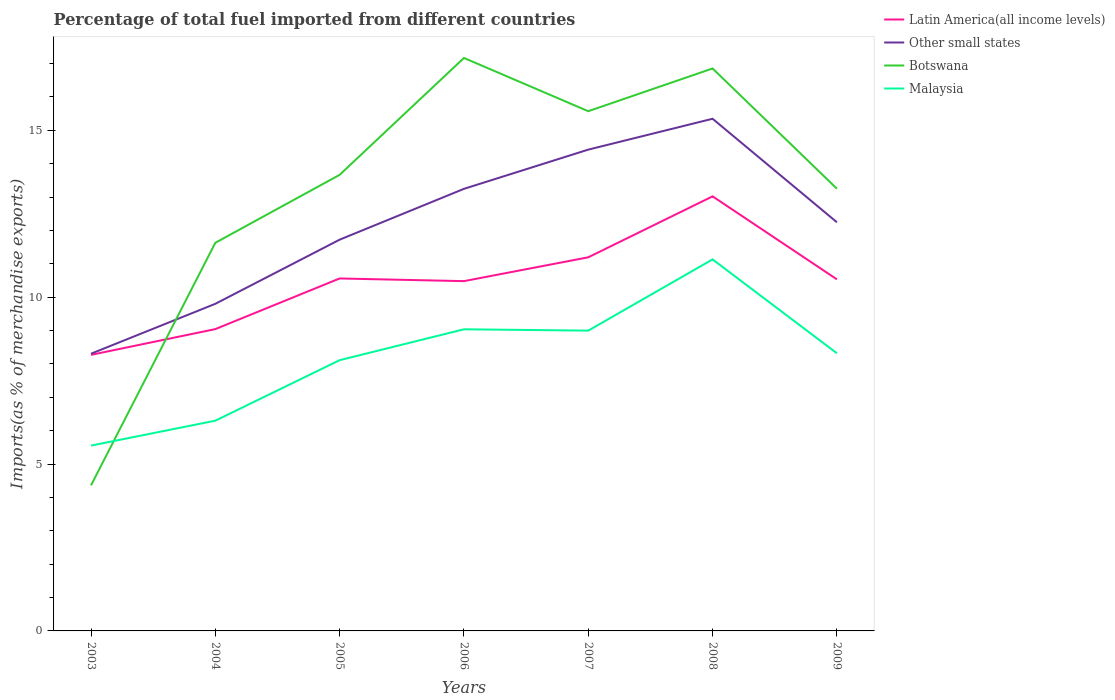Across all years, what is the maximum percentage of imports to different countries in Botswana?
Provide a short and direct response. 4.36. What is the total percentage of imports to different countries in Malaysia in the graph?
Your answer should be compact. -0.93. What is the difference between the highest and the second highest percentage of imports to different countries in Botswana?
Your response must be concise. 12.81. How many years are there in the graph?
Offer a very short reply. 7. Does the graph contain grids?
Provide a short and direct response. No. How many legend labels are there?
Your answer should be compact. 4. How are the legend labels stacked?
Your response must be concise. Vertical. What is the title of the graph?
Your response must be concise. Percentage of total fuel imported from different countries. Does "Switzerland" appear as one of the legend labels in the graph?
Your response must be concise. No. What is the label or title of the Y-axis?
Keep it short and to the point. Imports(as % of merchandise exports). What is the Imports(as % of merchandise exports) of Latin America(all income levels) in 2003?
Provide a succinct answer. 8.27. What is the Imports(as % of merchandise exports) in Other small states in 2003?
Offer a very short reply. 8.31. What is the Imports(as % of merchandise exports) of Botswana in 2003?
Make the answer very short. 4.36. What is the Imports(as % of merchandise exports) of Malaysia in 2003?
Provide a short and direct response. 5.55. What is the Imports(as % of merchandise exports) of Latin America(all income levels) in 2004?
Ensure brevity in your answer.  9.04. What is the Imports(as % of merchandise exports) of Other small states in 2004?
Your answer should be compact. 9.8. What is the Imports(as % of merchandise exports) of Botswana in 2004?
Ensure brevity in your answer.  11.63. What is the Imports(as % of merchandise exports) in Malaysia in 2004?
Offer a terse response. 6.3. What is the Imports(as % of merchandise exports) in Latin America(all income levels) in 2005?
Ensure brevity in your answer.  10.56. What is the Imports(as % of merchandise exports) of Other small states in 2005?
Keep it short and to the point. 11.72. What is the Imports(as % of merchandise exports) of Botswana in 2005?
Provide a short and direct response. 13.66. What is the Imports(as % of merchandise exports) in Malaysia in 2005?
Ensure brevity in your answer.  8.11. What is the Imports(as % of merchandise exports) of Latin America(all income levels) in 2006?
Your answer should be very brief. 10.48. What is the Imports(as % of merchandise exports) of Other small states in 2006?
Make the answer very short. 13.25. What is the Imports(as % of merchandise exports) of Botswana in 2006?
Offer a very short reply. 17.17. What is the Imports(as % of merchandise exports) of Malaysia in 2006?
Your response must be concise. 9.04. What is the Imports(as % of merchandise exports) in Latin America(all income levels) in 2007?
Offer a terse response. 11.19. What is the Imports(as % of merchandise exports) in Other small states in 2007?
Offer a very short reply. 14.42. What is the Imports(as % of merchandise exports) of Botswana in 2007?
Provide a short and direct response. 15.57. What is the Imports(as % of merchandise exports) in Malaysia in 2007?
Offer a very short reply. 9. What is the Imports(as % of merchandise exports) of Latin America(all income levels) in 2008?
Your answer should be very brief. 13.02. What is the Imports(as % of merchandise exports) in Other small states in 2008?
Keep it short and to the point. 15.34. What is the Imports(as % of merchandise exports) of Botswana in 2008?
Make the answer very short. 16.85. What is the Imports(as % of merchandise exports) of Malaysia in 2008?
Provide a succinct answer. 11.13. What is the Imports(as % of merchandise exports) in Latin America(all income levels) in 2009?
Your answer should be very brief. 10.53. What is the Imports(as % of merchandise exports) of Other small states in 2009?
Your answer should be very brief. 12.24. What is the Imports(as % of merchandise exports) of Botswana in 2009?
Provide a short and direct response. 13.25. What is the Imports(as % of merchandise exports) of Malaysia in 2009?
Provide a short and direct response. 8.32. Across all years, what is the maximum Imports(as % of merchandise exports) of Latin America(all income levels)?
Make the answer very short. 13.02. Across all years, what is the maximum Imports(as % of merchandise exports) in Other small states?
Provide a succinct answer. 15.34. Across all years, what is the maximum Imports(as % of merchandise exports) in Botswana?
Ensure brevity in your answer.  17.17. Across all years, what is the maximum Imports(as % of merchandise exports) in Malaysia?
Offer a very short reply. 11.13. Across all years, what is the minimum Imports(as % of merchandise exports) of Latin America(all income levels)?
Ensure brevity in your answer.  8.27. Across all years, what is the minimum Imports(as % of merchandise exports) of Other small states?
Your answer should be compact. 8.31. Across all years, what is the minimum Imports(as % of merchandise exports) in Botswana?
Your answer should be very brief. 4.36. Across all years, what is the minimum Imports(as % of merchandise exports) of Malaysia?
Offer a very short reply. 5.55. What is the total Imports(as % of merchandise exports) in Latin America(all income levels) in the graph?
Ensure brevity in your answer.  73.1. What is the total Imports(as % of merchandise exports) in Other small states in the graph?
Keep it short and to the point. 85.08. What is the total Imports(as % of merchandise exports) in Botswana in the graph?
Make the answer very short. 92.49. What is the total Imports(as % of merchandise exports) in Malaysia in the graph?
Give a very brief answer. 57.45. What is the difference between the Imports(as % of merchandise exports) of Latin America(all income levels) in 2003 and that in 2004?
Give a very brief answer. -0.77. What is the difference between the Imports(as % of merchandise exports) in Other small states in 2003 and that in 2004?
Provide a succinct answer. -1.5. What is the difference between the Imports(as % of merchandise exports) in Botswana in 2003 and that in 2004?
Give a very brief answer. -7.27. What is the difference between the Imports(as % of merchandise exports) of Malaysia in 2003 and that in 2004?
Give a very brief answer. -0.75. What is the difference between the Imports(as % of merchandise exports) of Latin America(all income levels) in 2003 and that in 2005?
Your answer should be compact. -2.29. What is the difference between the Imports(as % of merchandise exports) in Other small states in 2003 and that in 2005?
Make the answer very short. -3.42. What is the difference between the Imports(as % of merchandise exports) of Botswana in 2003 and that in 2005?
Provide a succinct answer. -9.3. What is the difference between the Imports(as % of merchandise exports) of Malaysia in 2003 and that in 2005?
Provide a short and direct response. -2.56. What is the difference between the Imports(as % of merchandise exports) in Latin America(all income levels) in 2003 and that in 2006?
Ensure brevity in your answer.  -2.21. What is the difference between the Imports(as % of merchandise exports) in Other small states in 2003 and that in 2006?
Keep it short and to the point. -4.94. What is the difference between the Imports(as % of merchandise exports) in Botswana in 2003 and that in 2006?
Your response must be concise. -12.81. What is the difference between the Imports(as % of merchandise exports) of Malaysia in 2003 and that in 2006?
Provide a succinct answer. -3.48. What is the difference between the Imports(as % of merchandise exports) of Latin America(all income levels) in 2003 and that in 2007?
Your answer should be very brief. -2.92. What is the difference between the Imports(as % of merchandise exports) of Other small states in 2003 and that in 2007?
Provide a short and direct response. -6.11. What is the difference between the Imports(as % of merchandise exports) in Botswana in 2003 and that in 2007?
Give a very brief answer. -11.21. What is the difference between the Imports(as % of merchandise exports) of Malaysia in 2003 and that in 2007?
Give a very brief answer. -3.44. What is the difference between the Imports(as % of merchandise exports) of Latin America(all income levels) in 2003 and that in 2008?
Keep it short and to the point. -4.75. What is the difference between the Imports(as % of merchandise exports) in Other small states in 2003 and that in 2008?
Your answer should be very brief. -7.04. What is the difference between the Imports(as % of merchandise exports) in Botswana in 2003 and that in 2008?
Provide a short and direct response. -12.49. What is the difference between the Imports(as % of merchandise exports) of Malaysia in 2003 and that in 2008?
Provide a succinct answer. -5.58. What is the difference between the Imports(as % of merchandise exports) of Latin America(all income levels) in 2003 and that in 2009?
Offer a very short reply. -2.26. What is the difference between the Imports(as % of merchandise exports) of Other small states in 2003 and that in 2009?
Provide a succinct answer. -3.94. What is the difference between the Imports(as % of merchandise exports) of Botswana in 2003 and that in 2009?
Provide a succinct answer. -8.89. What is the difference between the Imports(as % of merchandise exports) in Malaysia in 2003 and that in 2009?
Provide a short and direct response. -2.77. What is the difference between the Imports(as % of merchandise exports) of Latin America(all income levels) in 2004 and that in 2005?
Provide a short and direct response. -1.52. What is the difference between the Imports(as % of merchandise exports) in Other small states in 2004 and that in 2005?
Give a very brief answer. -1.92. What is the difference between the Imports(as % of merchandise exports) of Botswana in 2004 and that in 2005?
Make the answer very short. -2.04. What is the difference between the Imports(as % of merchandise exports) in Malaysia in 2004 and that in 2005?
Offer a terse response. -1.81. What is the difference between the Imports(as % of merchandise exports) in Latin America(all income levels) in 2004 and that in 2006?
Make the answer very short. -1.44. What is the difference between the Imports(as % of merchandise exports) of Other small states in 2004 and that in 2006?
Your answer should be very brief. -3.44. What is the difference between the Imports(as % of merchandise exports) of Botswana in 2004 and that in 2006?
Make the answer very short. -5.54. What is the difference between the Imports(as % of merchandise exports) in Malaysia in 2004 and that in 2006?
Your answer should be compact. -2.74. What is the difference between the Imports(as % of merchandise exports) of Latin America(all income levels) in 2004 and that in 2007?
Provide a short and direct response. -2.15. What is the difference between the Imports(as % of merchandise exports) in Other small states in 2004 and that in 2007?
Your answer should be compact. -4.62. What is the difference between the Imports(as % of merchandise exports) in Botswana in 2004 and that in 2007?
Offer a very short reply. -3.94. What is the difference between the Imports(as % of merchandise exports) of Malaysia in 2004 and that in 2007?
Provide a short and direct response. -2.7. What is the difference between the Imports(as % of merchandise exports) in Latin America(all income levels) in 2004 and that in 2008?
Your answer should be very brief. -3.98. What is the difference between the Imports(as % of merchandise exports) of Other small states in 2004 and that in 2008?
Provide a short and direct response. -5.54. What is the difference between the Imports(as % of merchandise exports) of Botswana in 2004 and that in 2008?
Provide a succinct answer. -5.22. What is the difference between the Imports(as % of merchandise exports) of Malaysia in 2004 and that in 2008?
Ensure brevity in your answer.  -4.83. What is the difference between the Imports(as % of merchandise exports) in Latin America(all income levels) in 2004 and that in 2009?
Give a very brief answer. -1.49. What is the difference between the Imports(as % of merchandise exports) in Other small states in 2004 and that in 2009?
Make the answer very short. -2.44. What is the difference between the Imports(as % of merchandise exports) in Botswana in 2004 and that in 2009?
Keep it short and to the point. -1.62. What is the difference between the Imports(as % of merchandise exports) of Malaysia in 2004 and that in 2009?
Keep it short and to the point. -2.02. What is the difference between the Imports(as % of merchandise exports) in Latin America(all income levels) in 2005 and that in 2006?
Offer a terse response. 0.08. What is the difference between the Imports(as % of merchandise exports) of Other small states in 2005 and that in 2006?
Give a very brief answer. -1.52. What is the difference between the Imports(as % of merchandise exports) in Botswana in 2005 and that in 2006?
Your response must be concise. -3.5. What is the difference between the Imports(as % of merchandise exports) of Malaysia in 2005 and that in 2006?
Give a very brief answer. -0.93. What is the difference between the Imports(as % of merchandise exports) of Latin America(all income levels) in 2005 and that in 2007?
Give a very brief answer. -0.63. What is the difference between the Imports(as % of merchandise exports) in Other small states in 2005 and that in 2007?
Make the answer very short. -2.7. What is the difference between the Imports(as % of merchandise exports) in Botswana in 2005 and that in 2007?
Make the answer very short. -1.91. What is the difference between the Imports(as % of merchandise exports) in Malaysia in 2005 and that in 2007?
Ensure brevity in your answer.  -0.89. What is the difference between the Imports(as % of merchandise exports) of Latin America(all income levels) in 2005 and that in 2008?
Your answer should be very brief. -2.46. What is the difference between the Imports(as % of merchandise exports) in Other small states in 2005 and that in 2008?
Offer a very short reply. -3.62. What is the difference between the Imports(as % of merchandise exports) of Botswana in 2005 and that in 2008?
Offer a very short reply. -3.19. What is the difference between the Imports(as % of merchandise exports) in Malaysia in 2005 and that in 2008?
Your answer should be very brief. -3.02. What is the difference between the Imports(as % of merchandise exports) in Latin America(all income levels) in 2005 and that in 2009?
Make the answer very short. 0.03. What is the difference between the Imports(as % of merchandise exports) of Other small states in 2005 and that in 2009?
Provide a short and direct response. -0.52. What is the difference between the Imports(as % of merchandise exports) in Botswana in 2005 and that in 2009?
Provide a short and direct response. 0.42. What is the difference between the Imports(as % of merchandise exports) in Malaysia in 2005 and that in 2009?
Provide a succinct answer. -0.21. What is the difference between the Imports(as % of merchandise exports) in Latin America(all income levels) in 2006 and that in 2007?
Your response must be concise. -0.71. What is the difference between the Imports(as % of merchandise exports) of Other small states in 2006 and that in 2007?
Give a very brief answer. -1.17. What is the difference between the Imports(as % of merchandise exports) of Botswana in 2006 and that in 2007?
Make the answer very short. 1.6. What is the difference between the Imports(as % of merchandise exports) of Malaysia in 2006 and that in 2007?
Provide a short and direct response. 0.04. What is the difference between the Imports(as % of merchandise exports) in Latin America(all income levels) in 2006 and that in 2008?
Give a very brief answer. -2.54. What is the difference between the Imports(as % of merchandise exports) of Other small states in 2006 and that in 2008?
Offer a terse response. -2.1. What is the difference between the Imports(as % of merchandise exports) in Botswana in 2006 and that in 2008?
Offer a very short reply. 0.32. What is the difference between the Imports(as % of merchandise exports) in Malaysia in 2006 and that in 2008?
Provide a succinct answer. -2.09. What is the difference between the Imports(as % of merchandise exports) in Latin America(all income levels) in 2006 and that in 2009?
Offer a terse response. -0.05. What is the difference between the Imports(as % of merchandise exports) of Other small states in 2006 and that in 2009?
Give a very brief answer. 1. What is the difference between the Imports(as % of merchandise exports) of Botswana in 2006 and that in 2009?
Provide a succinct answer. 3.92. What is the difference between the Imports(as % of merchandise exports) of Malaysia in 2006 and that in 2009?
Your answer should be very brief. 0.72. What is the difference between the Imports(as % of merchandise exports) of Latin America(all income levels) in 2007 and that in 2008?
Ensure brevity in your answer.  -1.83. What is the difference between the Imports(as % of merchandise exports) of Other small states in 2007 and that in 2008?
Provide a short and direct response. -0.92. What is the difference between the Imports(as % of merchandise exports) in Botswana in 2007 and that in 2008?
Keep it short and to the point. -1.28. What is the difference between the Imports(as % of merchandise exports) in Malaysia in 2007 and that in 2008?
Offer a very short reply. -2.13. What is the difference between the Imports(as % of merchandise exports) in Latin America(all income levels) in 2007 and that in 2009?
Offer a very short reply. 0.66. What is the difference between the Imports(as % of merchandise exports) of Other small states in 2007 and that in 2009?
Provide a succinct answer. 2.18. What is the difference between the Imports(as % of merchandise exports) in Botswana in 2007 and that in 2009?
Make the answer very short. 2.32. What is the difference between the Imports(as % of merchandise exports) of Malaysia in 2007 and that in 2009?
Your response must be concise. 0.68. What is the difference between the Imports(as % of merchandise exports) of Latin America(all income levels) in 2008 and that in 2009?
Provide a succinct answer. 2.49. What is the difference between the Imports(as % of merchandise exports) in Other small states in 2008 and that in 2009?
Your response must be concise. 3.1. What is the difference between the Imports(as % of merchandise exports) of Botswana in 2008 and that in 2009?
Provide a short and direct response. 3.6. What is the difference between the Imports(as % of merchandise exports) in Malaysia in 2008 and that in 2009?
Offer a terse response. 2.81. What is the difference between the Imports(as % of merchandise exports) of Latin America(all income levels) in 2003 and the Imports(as % of merchandise exports) of Other small states in 2004?
Ensure brevity in your answer.  -1.53. What is the difference between the Imports(as % of merchandise exports) of Latin America(all income levels) in 2003 and the Imports(as % of merchandise exports) of Botswana in 2004?
Your response must be concise. -3.36. What is the difference between the Imports(as % of merchandise exports) of Latin America(all income levels) in 2003 and the Imports(as % of merchandise exports) of Malaysia in 2004?
Your answer should be very brief. 1.97. What is the difference between the Imports(as % of merchandise exports) in Other small states in 2003 and the Imports(as % of merchandise exports) in Botswana in 2004?
Your response must be concise. -3.32. What is the difference between the Imports(as % of merchandise exports) in Other small states in 2003 and the Imports(as % of merchandise exports) in Malaysia in 2004?
Keep it short and to the point. 2.01. What is the difference between the Imports(as % of merchandise exports) of Botswana in 2003 and the Imports(as % of merchandise exports) of Malaysia in 2004?
Your answer should be compact. -1.94. What is the difference between the Imports(as % of merchandise exports) in Latin America(all income levels) in 2003 and the Imports(as % of merchandise exports) in Other small states in 2005?
Your response must be concise. -3.45. What is the difference between the Imports(as % of merchandise exports) of Latin America(all income levels) in 2003 and the Imports(as % of merchandise exports) of Botswana in 2005?
Your response must be concise. -5.39. What is the difference between the Imports(as % of merchandise exports) of Latin America(all income levels) in 2003 and the Imports(as % of merchandise exports) of Malaysia in 2005?
Provide a short and direct response. 0.16. What is the difference between the Imports(as % of merchandise exports) in Other small states in 2003 and the Imports(as % of merchandise exports) in Botswana in 2005?
Your response must be concise. -5.36. What is the difference between the Imports(as % of merchandise exports) in Other small states in 2003 and the Imports(as % of merchandise exports) in Malaysia in 2005?
Ensure brevity in your answer.  0.19. What is the difference between the Imports(as % of merchandise exports) of Botswana in 2003 and the Imports(as % of merchandise exports) of Malaysia in 2005?
Provide a succinct answer. -3.75. What is the difference between the Imports(as % of merchandise exports) of Latin America(all income levels) in 2003 and the Imports(as % of merchandise exports) of Other small states in 2006?
Provide a short and direct response. -4.97. What is the difference between the Imports(as % of merchandise exports) of Latin America(all income levels) in 2003 and the Imports(as % of merchandise exports) of Botswana in 2006?
Offer a very short reply. -8.9. What is the difference between the Imports(as % of merchandise exports) in Latin America(all income levels) in 2003 and the Imports(as % of merchandise exports) in Malaysia in 2006?
Your response must be concise. -0.77. What is the difference between the Imports(as % of merchandise exports) of Other small states in 2003 and the Imports(as % of merchandise exports) of Botswana in 2006?
Keep it short and to the point. -8.86. What is the difference between the Imports(as % of merchandise exports) in Other small states in 2003 and the Imports(as % of merchandise exports) in Malaysia in 2006?
Offer a terse response. -0.73. What is the difference between the Imports(as % of merchandise exports) of Botswana in 2003 and the Imports(as % of merchandise exports) of Malaysia in 2006?
Keep it short and to the point. -4.68. What is the difference between the Imports(as % of merchandise exports) in Latin America(all income levels) in 2003 and the Imports(as % of merchandise exports) in Other small states in 2007?
Your answer should be compact. -6.15. What is the difference between the Imports(as % of merchandise exports) in Latin America(all income levels) in 2003 and the Imports(as % of merchandise exports) in Botswana in 2007?
Make the answer very short. -7.3. What is the difference between the Imports(as % of merchandise exports) in Latin America(all income levels) in 2003 and the Imports(as % of merchandise exports) in Malaysia in 2007?
Keep it short and to the point. -0.73. What is the difference between the Imports(as % of merchandise exports) in Other small states in 2003 and the Imports(as % of merchandise exports) in Botswana in 2007?
Provide a succinct answer. -7.27. What is the difference between the Imports(as % of merchandise exports) in Other small states in 2003 and the Imports(as % of merchandise exports) in Malaysia in 2007?
Ensure brevity in your answer.  -0.69. What is the difference between the Imports(as % of merchandise exports) in Botswana in 2003 and the Imports(as % of merchandise exports) in Malaysia in 2007?
Provide a short and direct response. -4.64. What is the difference between the Imports(as % of merchandise exports) in Latin America(all income levels) in 2003 and the Imports(as % of merchandise exports) in Other small states in 2008?
Offer a terse response. -7.07. What is the difference between the Imports(as % of merchandise exports) of Latin America(all income levels) in 2003 and the Imports(as % of merchandise exports) of Botswana in 2008?
Your answer should be very brief. -8.58. What is the difference between the Imports(as % of merchandise exports) of Latin America(all income levels) in 2003 and the Imports(as % of merchandise exports) of Malaysia in 2008?
Provide a succinct answer. -2.86. What is the difference between the Imports(as % of merchandise exports) of Other small states in 2003 and the Imports(as % of merchandise exports) of Botswana in 2008?
Make the answer very short. -8.55. What is the difference between the Imports(as % of merchandise exports) in Other small states in 2003 and the Imports(as % of merchandise exports) in Malaysia in 2008?
Your response must be concise. -2.83. What is the difference between the Imports(as % of merchandise exports) of Botswana in 2003 and the Imports(as % of merchandise exports) of Malaysia in 2008?
Your response must be concise. -6.77. What is the difference between the Imports(as % of merchandise exports) in Latin America(all income levels) in 2003 and the Imports(as % of merchandise exports) in Other small states in 2009?
Offer a very short reply. -3.97. What is the difference between the Imports(as % of merchandise exports) in Latin America(all income levels) in 2003 and the Imports(as % of merchandise exports) in Botswana in 2009?
Offer a very short reply. -4.98. What is the difference between the Imports(as % of merchandise exports) in Latin America(all income levels) in 2003 and the Imports(as % of merchandise exports) in Malaysia in 2009?
Keep it short and to the point. -0.05. What is the difference between the Imports(as % of merchandise exports) of Other small states in 2003 and the Imports(as % of merchandise exports) of Botswana in 2009?
Keep it short and to the point. -4.94. What is the difference between the Imports(as % of merchandise exports) in Other small states in 2003 and the Imports(as % of merchandise exports) in Malaysia in 2009?
Your answer should be very brief. -0.01. What is the difference between the Imports(as % of merchandise exports) of Botswana in 2003 and the Imports(as % of merchandise exports) of Malaysia in 2009?
Your answer should be compact. -3.96. What is the difference between the Imports(as % of merchandise exports) of Latin America(all income levels) in 2004 and the Imports(as % of merchandise exports) of Other small states in 2005?
Ensure brevity in your answer.  -2.68. What is the difference between the Imports(as % of merchandise exports) of Latin America(all income levels) in 2004 and the Imports(as % of merchandise exports) of Botswana in 2005?
Offer a very short reply. -4.62. What is the difference between the Imports(as % of merchandise exports) in Latin America(all income levels) in 2004 and the Imports(as % of merchandise exports) in Malaysia in 2005?
Your answer should be very brief. 0.93. What is the difference between the Imports(as % of merchandise exports) of Other small states in 2004 and the Imports(as % of merchandise exports) of Botswana in 2005?
Provide a succinct answer. -3.86. What is the difference between the Imports(as % of merchandise exports) in Other small states in 2004 and the Imports(as % of merchandise exports) in Malaysia in 2005?
Keep it short and to the point. 1.69. What is the difference between the Imports(as % of merchandise exports) in Botswana in 2004 and the Imports(as % of merchandise exports) in Malaysia in 2005?
Offer a terse response. 3.52. What is the difference between the Imports(as % of merchandise exports) of Latin America(all income levels) in 2004 and the Imports(as % of merchandise exports) of Other small states in 2006?
Your answer should be very brief. -4.2. What is the difference between the Imports(as % of merchandise exports) in Latin America(all income levels) in 2004 and the Imports(as % of merchandise exports) in Botswana in 2006?
Give a very brief answer. -8.12. What is the difference between the Imports(as % of merchandise exports) in Latin America(all income levels) in 2004 and the Imports(as % of merchandise exports) in Malaysia in 2006?
Provide a short and direct response. 0.01. What is the difference between the Imports(as % of merchandise exports) in Other small states in 2004 and the Imports(as % of merchandise exports) in Botswana in 2006?
Keep it short and to the point. -7.37. What is the difference between the Imports(as % of merchandise exports) of Other small states in 2004 and the Imports(as % of merchandise exports) of Malaysia in 2006?
Give a very brief answer. 0.76. What is the difference between the Imports(as % of merchandise exports) of Botswana in 2004 and the Imports(as % of merchandise exports) of Malaysia in 2006?
Ensure brevity in your answer.  2.59. What is the difference between the Imports(as % of merchandise exports) of Latin America(all income levels) in 2004 and the Imports(as % of merchandise exports) of Other small states in 2007?
Keep it short and to the point. -5.38. What is the difference between the Imports(as % of merchandise exports) in Latin America(all income levels) in 2004 and the Imports(as % of merchandise exports) in Botswana in 2007?
Provide a succinct answer. -6.53. What is the difference between the Imports(as % of merchandise exports) of Latin America(all income levels) in 2004 and the Imports(as % of merchandise exports) of Malaysia in 2007?
Your answer should be compact. 0.05. What is the difference between the Imports(as % of merchandise exports) of Other small states in 2004 and the Imports(as % of merchandise exports) of Botswana in 2007?
Give a very brief answer. -5.77. What is the difference between the Imports(as % of merchandise exports) of Other small states in 2004 and the Imports(as % of merchandise exports) of Malaysia in 2007?
Keep it short and to the point. 0.8. What is the difference between the Imports(as % of merchandise exports) in Botswana in 2004 and the Imports(as % of merchandise exports) in Malaysia in 2007?
Ensure brevity in your answer.  2.63. What is the difference between the Imports(as % of merchandise exports) in Latin America(all income levels) in 2004 and the Imports(as % of merchandise exports) in Other small states in 2008?
Your answer should be compact. -6.3. What is the difference between the Imports(as % of merchandise exports) in Latin America(all income levels) in 2004 and the Imports(as % of merchandise exports) in Botswana in 2008?
Make the answer very short. -7.81. What is the difference between the Imports(as % of merchandise exports) of Latin America(all income levels) in 2004 and the Imports(as % of merchandise exports) of Malaysia in 2008?
Your answer should be compact. -2.09. What is the difference between the Imports(as % of merchandise exports) in Other small states in 2004 and the Imports(as % of merchandise exports) in Botswana in 2008?
Ensure brevity in your answer.  -7.05. What is the difference between the Imports(as % of merchandise exports) in Other small states in 2004 and the Imports(as % of merchandise exports) in Malaysia in 2008?
Give a very brief answer. -1.33. What is the difference between the Imports(as % of merchandise exports) of Botswana in 2004 and the Imports(as % of merchandise exports) of Malaysia in 2008?
Make the answer very short. 0.5. What is the difference between the Imports(as % of merchandise exports) of Latin America(all income levels) in 2004 and the Imports(as % of merchandise exports) of Other small states in 2009?
Provide a short and direct response. -3.2. What is the difference between the Imports(as % of merchandise exports) in Latin America(all income levels) in 2004 and the Imports(as % of merchandise exports) in Botswana in 2009?
Ensure brevity in your answer.  -4.21. What is the difference between the Imports(as % of merchandise exports) in Latin America(all income levels) in 2004 and the Imports(as % of merchandise exports) in Malaysia in 2009?
Provide a short and direct response. 0.72. What is the difference between the Imports(as % of merchandise exports) of Other small states in 2004 and the Imports(as % of merchandise exports) of Botswana in 2009?
Offer a very short reply. -3.45. What is the difference between the Imports(as % of merchandise exports) of Other small states in 2004 and the Imports(as % of merchandise exports) of Malaysia in 2009?
Offer a very short reply. 1.48. What is the difference between the Imports(as % of merchandise exports) in Botswana in 2004 and the Imports(as % of merchandise exports) in Malaysia in 2009?
Make the answer very short. 3.31. What is the difference between the Imports(as % of merchandise exports) in Latin America(all income levels) in 2005 and the Imports(as % of merchandise exports) in Other small states in 2006?
Make the answer very short. -2.69. What is the difference between the Imports(as % of merchandise exports) in Latin America(all income levels) in 2005 and the Imports(as % of merchandise exports) in Botswana in 2006?
Your answer should be very brief. -6.61. What is the difference between the Imports(as % of merchandise exports) of Latin America(all income levels) in 2005 and the Imports(as % of merchandise exports) of Malaysia in 2006?
Keep it short and to the point. 1.52. What is the difference between the Imports(as % of merchandise exports) of Other small states in 2005 and the Imports(as % of merchandise exports) of Botswana in 2006?
Ensure brevity in your answer.  -5.44. What is the difference between the Imports(as % of merchandise exports) of Other small states in 2005 and the Imports(as % of merchandise exports) of Malaysia in 2006?
Ensure brevity in your answer.  2.69. What is the difference between the Imports(as % of merchandise exports) in Botswana in 2005 and the Imports(as % of merchandise exports) in Malaysia in 2006?
Make the answer very short. 4.63. What is the difference between the Imports(as % of merchandise exports) in Latin America(all income levels) in 2005 and the Imports(as % of merchandise exports) in Other small states in 2007?
Ensure brevity in your answer.  -3.86. What is the difference between the Imports(as % of merchandise exports) of Latin America(all income levels) in 2005 and the Imports(as % of merchandise exports) of Botswana in 2007?
Provide a succinct answer. -5.01. What is the difference between the Imports(as % of merchandise exports) in Latin America(all income levels) in 2005 and the Imports(as % of merchandise exports) in Malaysia in 2007?
Ensure brevity in your answer.  1.56. What is the difference between the Imports(as % of merchandise exports) of Other small states in 2005 and the Imports(as % of merchandise exports) of Botswana in 2007?
Provide a short and direct response. -3.85. What is the difference between the Imports(as % of merchandise exports) of Other small states in 2005 and the Imports(as % of merchandise exports) of Malaysia in 2007?
Provide a short and direct response. 2.72. What is the difference between the Imports(as % of merchandise exports) of Botswana in 2005 and the Imports(as % of merchandise exports) of Malaysia in 2007?
Give a very brief answer. 4.67. What is the difference between the Imports(as % of merchandise exports) of Latin America(all income levels) in 2005 and the Imports(as % of merchandise exports) of Other small states in 2008?
Provide a short and direct response. -4.78. What is the difference between the Imports(as % of merchandise exports) in Latin America(all income levels) in 2005 and the Imports(as % of merchandise exports) in Botswana in 2008?
Give a very brief answer. -6.29. What is the difference between the Imports(as % of merchandise exports) of Latin America(all income levels) in 2005 and the Imports(as % of merchandise exports) of Malaysia in 2008?
Your answer should be very brief. -0.57. What is the difference between the Imports(as % of merchandise exports) in Other small states in 2005 and the Imports(as % of merchandise exports) in Botswana in 2008?
Your response must be concise. -5.13. What is the difference between the Imports(as % of merchandise exports) in Other small states in 2005 and the Imports(as % of merchandise exports) in Malaysia in 2008?
Offer a very short reply. 0.59. What is the difference between the Imports(as % of merchandise exports) of Botswana in 2005 and the Imports(as % of merchandise exports) of Malaysia in 2008?
Your answer should be compact. 2.53. What is the difference between the Imports(as % of merchandise exports) in Latin America(all income levels) in 2005 and the Imports(as % of merchandise exports) in Other small states in 2009?
Keep it short and to the point. -1.68. What is the difference between the Imports(as % of merchandise exports) of Latin America(all income levels) in 2005 and the Imports(as % of merchandise exports) of Botswana in 2009?
Ensure brevity in your answer.  -2.69. What is the difference between the Imports(as % of merchandise exports) in Latin America(all income levels) in 2005 and the Imports(as % of merchandise exports) in Malaysia in 2009?
Give a very brief answer. 2.24. What is the difference between the Imports(as % of merchandise exports) of Other small states in 2005 and the Imports(as % of merchandise exports) of Botswana in 2009?
Give a very brief answer. -1.53. What is the difference between the Imports(as % of merchandise exports) in Other small states in 2005 and the Imports(as % of merchandise exports) in Malaysia in 2009?
Ensure brevity in your answer.  3.4. What is the difference between the Imports(as % of merchandise exports) of Botswana in 2005 and the Imports(as % of merchandise exports) of Malaysia in 2009?
Your response must be concise. 5.35. What is the difference between the Imports(as % of merchandise exports) in Latin America(all income levels) in 2006 and the Imports(as % of merchandise exports) in Other small states in 2007?
Provide a succinct answer. -3.94. What is the difference between the Imports(as % of merchandise exports) of Latin America(all income levels) in 2006 and the Imports(as % of merchandise exports) of Botswana in 2007?
Offer a terse response. -5.09. What is the difference between the Imports(as % of merchandise exports) of Latin America(all income levels) in 2006 and the Imports(as % of merchandise exports) of Malaysia in 2007?
Your response must be concise. 1.48. What is the difference between the Imports(as % of merchandise exports) of Other small states in 2006 and the Imports(as % of merchandise exports) of Botswana in 2007?
Give a very brief answer. -2.33. What is the difference between the Imports(as % of merchandise exports) of Other small states in 2006 and the Imports(as % of merchandise exports) of Malaysia in 2007?
Your answer should be compact. 4.25. What is the difference between the Imports(as % of merchandise exports) in Botswana in 2006 and the Imports(as % of merchandise exports) in Malaysia in 2007?
Keep it short and to the point. 8.17. What is the difference between the Imports(as % of merchandise exports) of Latin America(all income levels) in 2006 and the Imports(as % of merchandise exports) of Other small states in 2008?
Your answer should be compact. -4.86. What is the difference between the Imports(as % of merchandise exports) of Latin America(all income levels) in 2006 and the Imports(as % of merchandise exports) of Botswana in 2008?
Your answer should be very brief. -6.37. What is the difference between the Imports(as % of merchandise exports) in Latin America(all income levels) in 2006 and the Imports(as % of merchandise exports) in Malaysia in 2008?
Provide a short and direct response. -0.65. What is the difference between the Imports(as % of merchandise exports) of Other small states in 2006 and the Imports(as % of merchandise exports) of Botswana in 2008?
Give a very brief answer. -3.61. What is the difference between the Imports(as % of merchandise exports) of Other small states in 2006 and the Imports(as % of merchandise exports) of Malaysia in 2008?
Provide a short and direct response. 2.11. What is the difference between the Imports(as % of merchandise exports) in Botswana in 2006 and the Imports(as % of merchandise exports) in Malaysia in 2008?
Your response must be concise. 6.04. What is the difference between the Imports(as % of merchandise exports) in Latin America(all income levels) in 2006 and the Imports(as % of merchandise exports) in Other small states in 2009?
Provide a succinct answer. -1.76. What is the difference between the Imports(as % of merchandise exports) of Latin America(all income levels) in 2006 and the Imports(as % of merchandise exports) of Botswana in 2009?
Make the answer very short. -2.77. What is the difference between the Imports(as % of merchandise exports) of Latin America(all income levels) in 2006 and the Imports(as % of merchandise exports) of Malaysia in 2009?
Your answer should be very brief. 2.16. What is the difference between the Imports(as % of merchandise exports) of Other small states in 2006 and the Imports(as % of merchandise exports) of Botswana in 2009?
Provide a short and direct response. -0. What is the difference between the Imports(as % of merchandise exports) in Other small states in 2006 and the Imports(as % of merchandise exports) in Malaysia in 2009?
Your response must be concise. 4.93. What is the difference between the Imports(as % of merchandise exports) in Botswana in 2006 and the Imports(as % of merchandise exports) in Malaysia in 2009?
Offer a very short reply. 8.85. What is the difference between the Imports(as % of merchandise exports) in Latin America(all income levels) in 2007 and the Imports(as % of merchandise exports) in Other small states in 2008?
Provide a succinct answer. -4.15. What is the difference between the Imports(as % of merchandise exports) in Latin America(all income levels) in 2007 and the Imports(as % of merchandise exports) in Botswana in 2008?
Your answer should be very brief. -5.66. What is the difference between the Imports(as % of merchandise exports) of Latin America(all income levels) in 2007 and the Imports(as % of merchandise exports) of Malaysia in 2008?
Ensure brevity in your answer.  0.06. What is the difference between the Imports(as % of merchandise exports) in Other small states in 2007 and the Imports(as % of merchandise exports) in Botswana in 2008?
Offer a terse response. -2.43. What is the difference between the Imports(as % of merchandise exports) of Other small states in 2007 and the Imports(as % of merchandise exports) of Malaysia in 2008?
Provide a succinct answer. 3.29. What is the difference between the Imports(as % of merchandise exports) in Botswana in 2007 and the Imports(as % of merchandise exports) in Malaysia in 2008?
Offer a terse response. 4.44. What is the difference between the Imports(as % of merchandise exports) in Latin America(all income levels) in 2007 and the Imports(as % of merchandise exports) in Other small states in 2009?
Offer a very short reply. -1.05. What is the difference between the Imports(as % of merchandise exports) of Latin America(all income levels) in 2007 and the Imports(as % of merchandise exports) of Botswana in 2009?
Ensure brevity in your answer.  -2.06. What is the difference between the Imports(as % of merchandise exports) of Latin America(all income levels) in 2007 and the Imports(as % of merchandise exports) of Malaysia in 2009?
Your answer should be very brief. 2.88. What is the difference between the Imports(as % of merchandise exports) of Other small states in 2007 and the Imports(as % of merchandise exports) of Botswana in 2009?
Your response must be concise. 1.17. What is the difference between the Imports(as % of merchandise exports) in Other small states in 2007 and the Imports(as % of merchandise exports) in Malaysia in 2009?
Make the answer very short. 6.1. What is the difference between the Imports(as % of merchandise exports) of Botswana in 2007 and the Imports(as % of merchandise exports) of Malaysia in 2009?
Offer a terse response. 7.25. What is the difference between the Imports(as % of merchandise exports) of Latin America(all income levels) in 2008 and the Imports(as % of merchandise exports) of Other small states in 2009?
Ensure brevity in your answer.  0.78. What is the difference between the Imports(as % of merchandise exports) in Latin America(all income levels) in 2008 and the Imports(as % of merchandise exports) in Botswana in 2009?
Your answer should be very brief. -0.23. What is the difference between the Imports(as % of merchandise exports) of Latin America(all income levels) in 2008 and the Imports(as % of merchandise exports) of Malaysia in 2009?
Your response must be concise. 4.7. What is the difference between the Imports(as % of merchandise exports) in Other small states in 2008 and the Imports(as % of merchandise exports) in Botswana in 2009?
Your answer should be compact. 2.1. What is the difference between the Imports(as % of merchandise exports) of Other small states in 2008 and the Imports(as % of merchandise exports) of Malaysia in 2009?
Provide a succinct answer. 7.03. What is the difference between the Imports(as % of merchandise exports) in Botswana in 2008 and the Imports(as % of merchandise exports) in Malaysia in 2009?
Offer a terse response. 8.53. What is the average Imports(as % of merchandise exports) of Latin America(all income levels) per year?
Your response must be concise. 10.44. What is the average Imports(as % of merchandise exports) of Other small states per year?
Offer a terse response. 12.15. What is the average Imports(as % of merchandise exports) of Botswana per year?
Make the answer very short. 13.21. What is the average Imports(as % of merchandise exports) in Malaysia per year?
Make the answer very short. 8.21. In the year 2003, what is the difference between the Imports(as % of merchandise exports) in Latin America(all income levels) and Imports(as % of merchandise exports) in Other small states?
Provide a short and direct response. -0.03. In the year 2003, what is the difference between the Imports(as % of merchandise exports) of Latin America(all income levels) and Imports(as % of merchandise exports) of Botswana?
Ensure brevity in your answer.  3.91. In the year 2003, what is the difference between the Imports(as % of merchandise exports) in Latin America(all income levels) and Imports(as % of merchandise exports) in Malaysia?
Your answer should be very brief. 2.72. In the year 2003, what is the difference between the Imports(as % of merchandise exports) in Other small states and Imports(as % of merchandise exports) in Botswana?
Give a very brief answer. 3.94. In the year 2003, what is the difference between the Imports(as % of merchandise exports) in Other small states and Imports(as % of merchandise exports) in Malaysia?
Give a very brief answer. 2.75. In the year 2003, what is the difference between the Imports(as % of merchandise exports) of Botswana and Imports(as % of merchandise exports) of Malaysia?
Make the answer very short. -1.19. In the year 2004, what is the difference between the Imports(as % of merchandise exports) in Latin America(all income levels) and Imports(as % of merchandise exports) in Other small states?
Provide a succinct answer. -0.76. In the year 2004, what is the difference between the Imports(as % of merchandise exports) in Latin America(all income levels) and Imports(as % of merchandise exports) in Botswana?
Ensure brevity in your answer.  -2.59. In the year 2004, what is the difference between the Imports(as % of merchandise exports) of Latin America(all income levels) and Imports(as % of merchandise exports) of Malaysia?
Your answer should be compact. 2.74. In the year 2004, what is the difference between the Imports(as % of merchandise exports) in Other small states and Imports(as % of merchandise exports) in Botswana?
Make the answer very short. -1.83. In the year 2004, what is the difference between the Imports(as % of merchandise exports) in Other small states and Imports(as % of merchandise exports) in Malaysia?
Your answer should be compact. 3.5. In the year 2004, what is the difference between the Imports(as % of merchandise exports) in Botswana and Imports(as % of merchandise exports) in Malaysia?
Your response must be concise. 5.33. In the year 2005, what is the difference between the Imports(as % of merchandise exports) of Latin America(all income levels) and Imports(as % of merchandise exports) of Other small states?
Provide a short and direct response. -1.16. In the year 2005, what is the difference between the Imports(as % of merchandise exports) in Latin America(all income levels) and Imports(as % of merchandise exports) in Botswana?
Give a very brief answer. -3.1. In the year 2005, what is the difference between the Imports(as % of merchandise exports) of Latin America(all income levels) and Imports(as % of merchandise exports) of Malaysia?
Provide a succinct answer. 2.45. In the year 2005, what is the difference between the Imports(as % of merchandise exports) of Other small states and Imports(as % of merchandise exports) of Botswana?
Keep it short and to the point. -1.94. In the year 2005, what is the difference between the Imports(as % of merchandise exports) in Other small states and Imports(as % of merchandise exports) in Malaysia?
Offer a very short reply. 3.61. In the year 2005, what is the difference between the Imports(as % of merchandise exports) of Botswana and Imports(as % of merchandise exports) of Malaysia?
Offer a terse response. 5.55. In the year 2006, what is the difference between the Imports(as % of merchandise exports) of Latin America(all income levels) and Imports(as % of merchandise exports) of Other small states?
Your response must be concise. -2.77. In the year 2006, what is the difference between the Imports(as % of merchandise exports) in Latin America(all income levels) and Imports(as % of merchandise exports) in Botswana?
Your answer should be compact. -6.69. In the year 2006, what is the difference between the Imports(as % of merchandise exports) of Latin America(all income levels) and Imports(as % of merchandise exports) of Malaysia?
Your answer should be compact. 1.44. In the year 2006, what is the difference between the Imports(as % of merchandise exports) of Other small states and Imports(as % of merchandise exports) of Botswana?
Keep it short and to the point. -3.92. In the year 2006, what is the difference between the Imports(as % of merchandise exports) of Other small states and Imports(as % of merchandise exports) of Malaysia?
Provide a succinct answer. 4.21. In the year 2006, what is the difference between the Imports(as % of merchandise exports) in Botswana and Imports(as % of merchandise exports) in Malaysia?
Provide a short and direct response. 8.13. In the year 2007, what is the difference between the Imports(as % of merchandise exports) in Latin America(all income levels) and Imports(as % of merchandise exports) in Other small states?
Offer a very short reply. -3.23. In the year 2007, what is the difference between the Imports(as % of merchandise exports) of Latin America(all income levels) and Imports(as % of merchandise exports) of Botswana?
Keep it short and to the point. -4.38. In the year 2007, what is the difference between the Imports(as % of merchandise exports) in Latin America(all income levels) and Imports(as % of merchandise exports) in Malaysia?
Provide a short and direct response. 2.2. In the year 2007, what is the difference between the Imports(as % of merchandise exports) of Other small states and Imports(as % of merchandise exports) of Botswana?
Keep it short and to the point. -1.15. In the year 2007, what is the difference between the Imports(as % of merchandise exports) of Other small states and Imports(as % of merchandise exports) of Malaysia?
Offer a very short reply. 5.42. In the year 2007, what is the difference between the Imports(as % of merchandise exports) of Botswana and Imports(as % of merchandise exports) of Malaysia?
Make the answer very short. 6.57. In the year 2008, what is the difference between the Imports(as % of merchandise exports) of Latin America(all income levels) and Imports(as % of merchandise exports) of Other small states?
Make the answer very short. -2.32. In the year 2008, what is the difference between the Imports(as % of merchandise exports) in Latin America(all income levels) and Imports(as % of merchandise exports) in Botswana?
Your answer should be compact. -3.83. In the year 2008, what is the difference between the Imports(as % of merchandise exports) of Latin America(all income levels) and Imports(as % of merchandise exports) of Malaysia?
Your answer should be very brief. 1.89. In the year 2008, what is the difference between the Imports(as % of merchandise exports) of Other small states and Imports(as % of merchandise exports) of Botswana?
Your response must be concise. -1.51. In the year 2008, what is the difference between the Imports(as % of merchandise exports) of Other small states and Imports(as % of merchandise exports) of Malaysia?
Your answer should be compact. 4.21. In the year 2008, what is the difference between the Imports(as % of merchandise exports) of Botswana and Imports(as % of merchandise exports) of Malaysia?
Give a very brief answer. 5.72. In the year 2009, what is the difference between the Imports(as % of merchandise exports) in Latin America(all income levels) and Imports(as % of merchandise exports) in Other small states?
Ensure brevity in your answer.  -1.71. In the year 2009, what is the difference between the Imports(as % of merchandise exports) in Latin America(all income levels) and Imports(as % of merchandise exports) in Botswana?
Your response must be concise. -2.72. In the year 2009, what is the difference between the Imports(as % of merchandise exports) of Latin America(all income levels) and Imports(as % of merchandise exports) of Malaysia?
Provide a succinct answer. 2.21. In the year 2009, what is the difference between the Imports(as % of merchandise exports) of Other small states and Imports(as % of merchandise exports) of Botswana?
Your response must be concise. -1.01. In the year 2009, what is the difference between the Imports(as % of merchandise exports) in Other small states and Imports(as % of merchandise exports) in Malaysia?
Ensure brevity in your answer.  3.93. In the year 2009, what is the difference between the Imports(as % of merchandise exports) in Botswana and Imports(as % of merchandise exports) in Malaysia?
Ensure brevity in your answer.  4.93. What is the ratio of the Imports(as % of merchandise exports) in Latin America(all income levels) in 2003 to that in 2004?
Your answer should be compact. 0.91. What is the ratio of the Imports(as % of merchandise exports) in Other small states in 2003 to that in 2004?
Ensure brevity in your answer.  0.85. What is the ratio of the Imports(as % of merchandise exports) of Malaysia in 2003 to that in 2004?
Give a very brief answer. 0.88. What is the ratio of the Imports(as % of merchandise exports) in Latin America(all income levels) in 2003 to that in 2005?
Your answer should be very brief. 0.78. What is the ratio of the Imports(as % of merchandise exports) of Other small states in 2003 to that in 2005?
Your answer should be very brief. 0.71. What is the ratio of the Imports(as % of merchandise exports) in Botswana in 2003 to that in 2005?
Your answer should be very brief. 0.32. What is the ratio of the Imports(as % of merchandise exports) of Malaysia in 2003 to that in 2005?
Offer a terse response. 0.68. What is the ratio of the Imports(as % of merchandise exports) in Latin America(all income levels) in 2003 to that in 2006?
Your answer should be compact. 0.79. What is the ratio of the Imports(as % of merchandise exports) of Other small states in 2003 to that in 2006?
Keep it short and to the point. 0.63. What is the ratio of the Imports(as % of merchandise exports) of Botswana in 2003 to that in 2006?
Make the answer very short. 0.25. What is the ratio of the Imports(as % of merchandise exports) of Malaysia in 2003 to that in 2006?
Offer a very short reply. 0.61. What is the ratio of the Imports(as % of merchandise exports) in Latin America(all income levels) in 2003 to that in 2007?
Your answer should be very brief. 0.74. What is the ratio of the Imports(as % of merchandise exports) in Other small states in 2003 to that in 2007?
Ensure brevity in your answer.  0.58. What is the ratio of the Imports(as % of merchandise exports) of Botswana in 2003 to that in 2007?
Your response must be concise. 0.28. What is the ratio of the Imports(as % of merchandise exports) of Malaysia in 2003 to that in 2007?
Your answer should be very brief. 0.62. What is the ratio of the Imports(as % of merchandise exports) in Latin America(all income levels) in 2003 to that in 2008?
Provide a succinct answer. 0.64. What is the ratio of the Imports(as % of merchandise exports) in Other small states in 2003 to that in 2008?
Provide a short and direct response. 0.54. What is the ratio of the Imports(as % of merchandise exports) in Botswana in 2003 to that in 2008?
Provide a succinct answer. 0.26. What is the ratio of the Imports(as % of merchandise exports) of Malaysia in 2003 to that in 2008?
Your answer should be compact. 0.5. What is the ratio of the Imports(as % of merchandise exports) of Latin America(all income levels) in 2003 to that in 2009?
Your response must be concise. 0.79. What is the ratio of the Imports(as % of merchandise exports) in Other small states in 2003 to that in 2009?
Keep it short and to the point. 0.68. What is the ratio of the Imports(as % of merchandise exports) of Botswana in 2003 to that in 2009?
Make the answer very short. 0.33. What is the ratio of the Imports(as % of merchandise exports) of Malaysia in 2003 to that in 2009?
Keep it short and to the point. 0.67. What is the ratio of the Imports(as % of merchandise exports) of Latin America(all income levels) in 2004 to that in 2005?
Your answer should be compact. 0.86. What is the ratio of the Imports(as % of merchandise exports) in Other small states in 2004 to that in 2005?
Make the answer very short. 0.84. What is the ratio of the Imports(as % of merchandise exports) of Botswana in 2004 to that in 2005?
Make the answer very short. 0.85. What is the ratio of the Imports(as % of merchandise exports) of Malaysia in 2004 to that in 2005?
Provide a succinct answer. 0.78. What is the ratio of the Imports(as % of merchandise exports) of Latin America(all income levels) in 2004 to that in 2006?
Give a very brief answer. 0.86. What is the ratio of the Imports(as % of merchandise exports) in Other small states in 2004 to that in 2006?
Your answer should be very brief. 0.74. What is the ratio of the Imports(as % of merchandise exports) of Botswana in 2004 to that in 2006?
Your answer should be very brief. 0.68. What is the ratio of the Imports(as % of merchandise exports) in Malaysia in 2004 to that in 2006?
Provide a short and direct response. 0.7. What is the ratio of the Imports(as % of merchandise exports) in Latin America(all income levels) in 2004 to that in 2007?
Ensure brevity in your answer.  0.81. What is the ratio of the Imports(as % of merchandise exports) of Other small states in 2004 to that in 2007?
Provide a short and direct response. 0.68. What is the ratio of the Imports(as % of merchandise exports) in Botswana in 2004 to that in 2007?
Your answer should be very brief. 0.75. What is the ratio of the Imports(as % of merchandise exports) in Malaysia in 2004 to that in 2007?
Give a very brief answer. 0.7. What is the ratio of the Imports(as % of merchandise exports) of Latin America(all income levels) in 2004 to that in 2008?
Your answer should be compact. 0.69. What is the ratio of the Imports(as % of merchandise exports) of Other small states in 2004 to that in 2008?
Make the answer very short. 0.64. What is the ratio of the Imports(as % of merchandise exports) of Botswana in 2004 to that in 2008?
Provide a succinct answer. 0.69. What is the ratio of the Imports(as % of merchandise exports) of Malaysia in 2004 to that in 2008?
Provide a succinct answer. 0.57. What is the ratio of the Imports(as % of merchandise exports) of Latin America(all income levels) in 2004 to that in 2009?
Your answer should be compact. 0.86. What is the ratio of the Imports(as % of merchandise exports) in Other small states in 2004 to that in 2009?
Make the answer very short. 0.8. What is the ratio of the Imports(as % of merchandise exports) of Botswana in 2004 to that in 2009?
Keep it short and to the point. 0.88. What is the ratio of the Imports(as % of merchandise exports) in Malaysia in 2004 to that in 2009?
Make the answer very short. 0.76. What is the ratio of the Imports(as % of merchandise exports) in Latin America(all income levels) in 2005 to that in 2006?
Ensure brevity in your answer.  1.01. What is the ratio of the Imports(as % of merchandise exports) in Other small states in 2005 to that in 2006?
Offer a very short reply. 0.89. What is the ratio of the Imports(as % of merchandise exports) in Botswana in 2005 to that in 2006?
Your response must be concise. 0.8. What is the ratio of the Imports(as % of merchandise exports) of Malaysia in 2005 to that in 2006?
Make the answer very short. 0.9. What is the ratio of the Imports(as % of merchandise exports) in Latin America(all income levels) in 2005 to that in 2007?
Give a very brief answer. 0.94. What is the ratio of the Imports(as % of merchandise exports) of Other small states in 2005 to that in 2007?
Your answer should be compact. 0.81. What is the ratio of the Imports(as % of merchandise exports) in Botswana in 2005 to that in 2007?
Provide a succinct answer. 0.88. What is the ratio of the Imports(as % of merchandise exports) in Malaysia in 2005 to that in 2007?
Offer a terse response. 0.9. What is the ratio of the Imports(as % of merchandise exports) in Latin America(all income levels) in 2005 to that in 2008?
Your answer should be compact. 0.81. What is the ratio of the Imports(as % of merchandise exports) of Other small states in 2005 to that in 2008?
Your response must be concise. 0.76. What is the ratio of the Imports(as % of merchandise exports) of Botswana in 2005 to that in 2008?
Keep it short and to the point. 0.81. What is the ratio of the Imports(as % of merchandise exports) of Malaysia in 2005 to that in 2008?
Your response must be concise. 0.73. What is the ratio of the Imports(as % of merchandise exports) in Other small states in 2005 to that in 2009?
Keep it short and to the point. 0.96. What is the ratio of the Imports(as % of merchandise exports) of Botswana in 2005 to that in 2009?
Make the answer very short. 1.03. What is the ratio of the Imports(as % of merchandise exports) of Malaysia in 2005 to that in 2009?
Offer a very short reply. 0.98. What is the ratio of the Imports(as % of merchandise exports) of Latin America(all income levels) in 2006 to that in 2007?
Ensure brevity in your answer.  0.94. What is the ratio of the Imports(as % of merchandise exports) of Other small states in 2006 to that in 2007?
Provide a short and direct response. 0.92. What is the ratio of the Imports(as % of merchandise exports) of Botswana in 2006 to that in 2007?
Offer a very short reply. 1.1. What is the ratio of the Imports(as % of merchandise exports) in Malaysia in 2006 to that in 2007?
Ensure brevity in your answer.  1. What is the ratio of the Imports(as % of merchandise exports) in Latin America(all income levels) in 2006 to that in 2008?
Give a very brief answer. 0.8. What is the ratio of the Imports(as % of merchandise exports) in Other small states in 2006 to that in 2008?
Provide a short and direct response. 0.86. What is the ratio of the Imports(as % of merchandise exports) of Botswana in 2006 to that in 2008?
Make the answer very short. 1.02. What is the ratio of the Imports(as % of merchandise exports) of Malaysia in 2006 to that in 2008?
Provide a short and direct response. 0.81. What is the ratio of the Imports(as % of merchandise exports) in Other small states in 2006 to that in 2009?
Provide a short and direct response. 1.08. What is the ratio of the Imports(as % of merchandise exports) in Botswana in 2006 to that in 2009?
Give a very brief answer. 1.3. What is the ratio of the Imports(as % of merchandise exports) of Malaysia in 2006 to that in 2009?
Provide a short and direct response. 1.09. What is the ratio of the Imports(as % of merchandise exports) of Latin America(all income levels) in 2007 to that in 2008?
Provide a succinct answer. 0.86. What is the ratio of the Imports(as % of merchandise exports) of Other small states in 2007 to that in 2008?
Ensure brevity in your answer.  0.94. What is the ratio of the Imports(as % of merchandise exports) in Botswana in 2007 to that in 2008?
Offer a terse response. 0.92. What is the ratio of the Imports(as % of merchandise exports) in Malaysia in 2007 to that in 2008?
Give a very brief answer. 0.81. What is the ratio of the Imports(as % of merchandise exports) in Latin America(all income levels) in 2007 to that in 2009?
Your answer should be compact. 1.06. What is the ratio of the Imports(as % of merchandise exports) in Other small states in 2007 to that in 2009?
Provide a short and direct response. 1.18. What is the ratio of the Imports(as % of merchandise exports) of Botswana in 2007 to that in 2009?
Make the answer very short. 1.18. What is the ratio of the Imports(as % of merchandise exports) in Malaysia in 2007 to that in 2009?
Offer a very short reply. 1.08. What is the ratio of the Imports(as % of merchandise exports) of Latin America(all income levels) in 2008 to that in 2009?
Keep it short and to the point. 1.24. What is the ratio of the Imports(as % of merchandise exports) in Other small states in 2008 to that in 2009?
Offer a very short reply. 1.25. What is the ratio of the Imports(as % of merchandise exports) of Botswana in 2008 to that in 2009?
Keep it short and to the point. 1.27. What is the ratio of the Imports(as % of merchandise exports) in Malaysia in 2008 to that in 2009?
Ensure brevity in your answer.  1.34. What is the difference between the highest and the second highest Imports(as % of merchandise exports) of Latin America(all income levels)?
Give a very brief answer. 1.83. What is the difference between the highest and the second highest Imports(as % of merchandise exports) of Other small states?
Give a very brief answer. 0.92. What is the difference between the highest and the second highest Imports(as % of merchandise exports) in Botswana?
Offer a terse response. 0.32. What is the difference between the highest and the second highest Imports(as % of merchandise exports) in Malaysia?
Give a very brief answer. 2.09. What is the difference between the highest and the lowest Imports(as % of merchandise exports) in Latin America(all income levels)?
Give a very brief answer. 4.75. What is the difference between the highest and the lowest Imports(as % of merchandise exports) in Other small states?
Your answer should be very brief. 7.04. What is the difference between the highest and the lowest Imports(as % of merchandise exports) in Botswana?
Make the answer very short. 12.81. What is the difference between the highest and the lowest Imports(as % of merchandise exports) in Malaysia?
Your answer should be very brief. 5.58. 